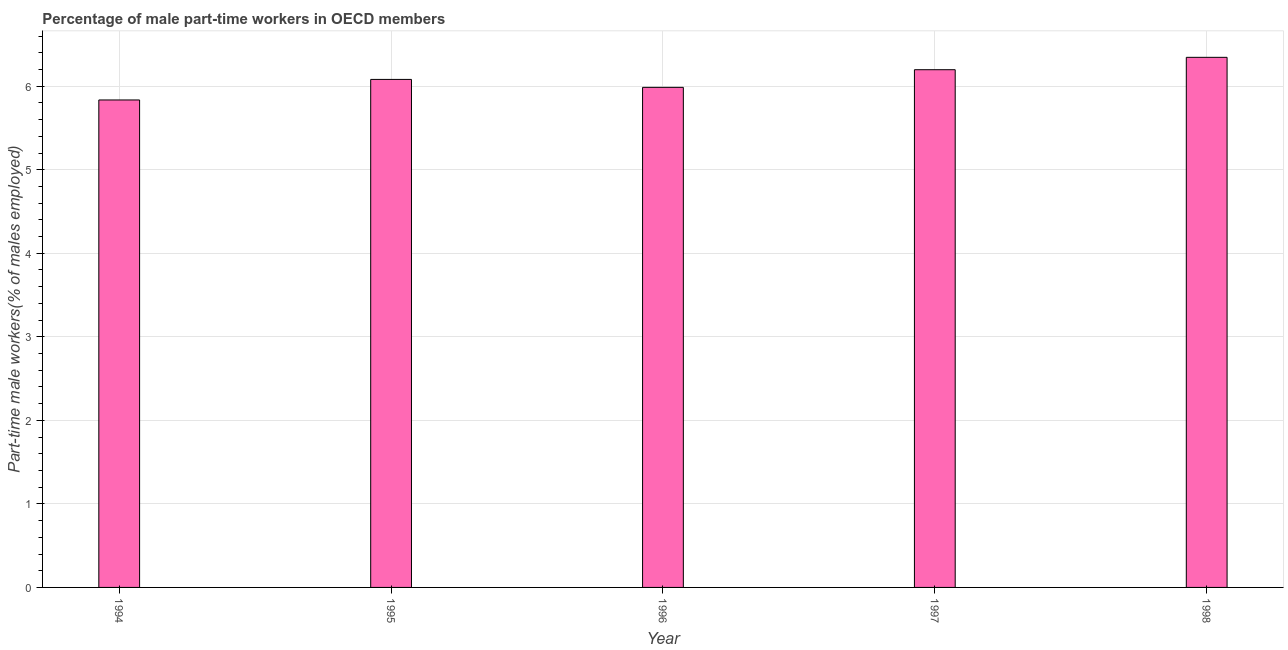What is the title of the graph?
Make the answer very short. Percentage of male part-time workers in OECD members. What is the label or title of the Y-axis?
Provide a short and direct response. Part-time male workers(% of males employed). What is the percentage of part-time male workers in 1997?
Your answer should be compact. 6.2. Across all years, what is the maximum percentage of part-time male workers?
Your answer should be compact. 6.35. Across all years, what is the minimum percentage of part-time male workers?
Your answer should be compact. 5.84. In which year was the percentage of part-time male workers maximum?
Make the answer very short. 1998. What is the sum of the percentage of part-time male workers?
Ensure brevity in your answer.  30.45. What is the difference between the percentage of part-time male workers in 1994 and 1995?
Your answer should be compact. -0.25. What is the average percentage of part-time male workers per year?
Offer a very short reply. 6.09. What is the median percentage of part-time male workers?
Offer a terse response. 6.08. In how many years, is the percentage of part-time male workers greater than 1 %?
Make the answer very short. 5. What is the ratio of the percentage of part-time male workers in 1995 to that in 1997?
Give a very brief answer. 0.98. Is the difference between the percentage of part-time male workers in 1994 and 1996 greater than the difference between any two years?
Give a very brief answer. No. What is the difference between the highest and the second highest percentage of part-time male workers?
Offer a very short reply. 0.15. Is the sum of the percentage of part-time male workers in 1995 and 1997 greater than the maximum percentage of part-time male workers across all years?
Provide a short and direct response. Yes. What is the difference between the highest and the lowest percentage of part-time male workers?
Offer a very short reply. 0.51. Are the values on the major ticks of Y-axis written in scientific E-notation?
Offer a terse response. No. What is the Part-time male workers(% of males employed) in 1994?
Your answer should be compact. 5.84. What is the Part-time male workers(% of males employed) in 1995?
Give a very brief answer. 6.08. What is the Part-time male workers(% of males employed) of 1996?
Your answer should be very brief. 5.99. What is the Part-time male workers(% of males employed) in 1997?
Give a very brief answer. 6.2. What is the Part-time male workers(% of males employed) of 1998?
Provide a succinct answer. 6.35. What is the difference between the Part-time male workers(% of males employed) in 1994 and 1995?
Offer a very short reply. -0.25. What is the difference between the Part-time male workers(% of males employed) in 1994 and 1996?
Give a very brief answer. -0.15. What is the difference between the Part-time male workers(% of males employed) in 1994 and 1997?
Provide a short and direct response. -0.36. What is the difference between the Part-time male workers(% of males employed) in 1994 and 1998?
Your response must be concise. -0.51. What is the difference between the Part-time male workers(% of males employed) in 1995 and 1996?
Provide a short and direct response. 0.1. What is the difference between the Part-time male workers(% of males employed) in 1995 and 1997?
Provide a succinct answer. -0.12. What is the difference between the Part-time male workers(% of males employed) in 1995 and 1998?
Your answer should be very brief. -0.26. What is the difference between the Part-time male workers(% of males employed) in 1996 and 1997?
Give a very brief answer. -0.21. What is the difference between the Part-time male workers(% of males employed) in 1996 and 1998?
Offer a terse response. -0.36. What is the difference between the Part-time male workers(% of males employed) in 1997 and 1998?
Make the answer very short. -0.15. What is the ratio of the Part-time male workers(% of males employed) in 1994 to that in 1996?
Provide a succinct answer. 0.97. What is the ratio of the Part-time male workers(% of males employed) in 1994 to that in 1997?
Make the answer very short. 0.94. What is the ratio of the Part-time male workers(% of males employed) in 1994 to that in 1998?
Your answer should be compact. 0.92. What is the ratio of the Part-time male workers(% of males employed) in 1995 to that in 1998?
Your response must be concise. 0.96. What is the ratio of the Part-time male workers(% of males employed) in 1996 to that in 1997?
Make the answer very short. 0.97. What is the ratio of the Part-time male workers(% of males employed) in 1996 to that in 1998?
Ensure brevity in your answer.  0.94. 